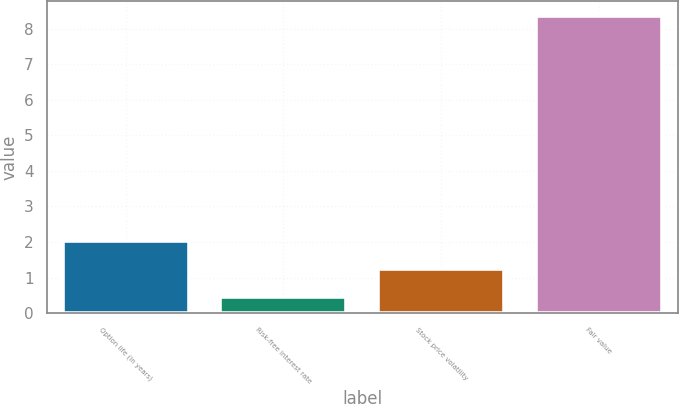Convert chart. <chart><loc_0><loc_0><loc_500><loc_500><bar_chart><fcel>Option life (in years)<fcel>Risk-free interest rate<fcel>Stock price volatility<fcel>Fair value<nl><fcel>2.02<fcel>0.44<fcel>1.23<fcel>8.36<nl></chart> 